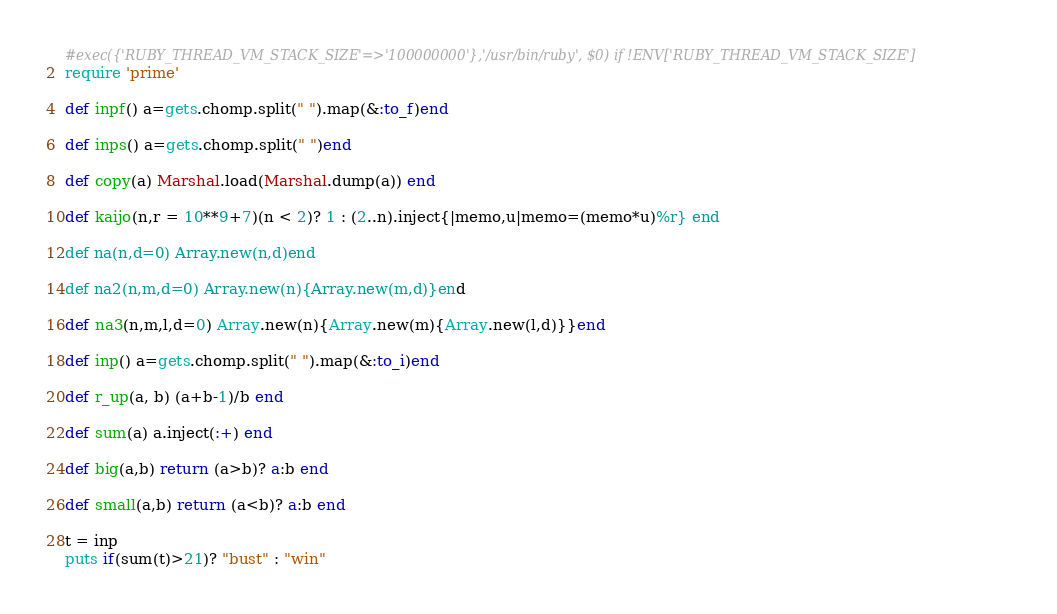<code> <loc_0><loc_0><loc_500><loc_500><_Ruby_>#exec({'RUBY_THREAD_VM_STACK_SIZE'=>'100000000'},'/usr/bin/ruby', $0) if !ENV['RUBY_THREAD_VM_STACK_SIZE']
require 'prime'

def inpf() a=gets.chomp.split(" ").map(&:to_f)end

def inps() a=gets.chomp.split(" ")end

def copy(a) Marshal.load(Marshal.dump(a)) end

def kaijo(n,r = 10**9+7)(n < 2)? 1 : (2..n).inject{|memo,u|memo=(memo*u)%r} end

def na(n,d=0) Array.new(n,d)end

def na2(n,m,d=0) Array.new(n){Array.new(m,d)}end

def na3(n,m,l,d=0) Array.new(n){Array.new(m){Array.new(l,d)}}end

def inp() a=gets.chomp.split(" ").map(&:to_i)end

def r_up(a, b) (a+b-1)/b end

def sum(a) a.inject(:+) end

def big(a,b) return (a>b)? a:b end

def small(a,b) return (a<b)? a:b end

t = inp
puts if(sum(t)>21)? "bust" : "win"</code> 